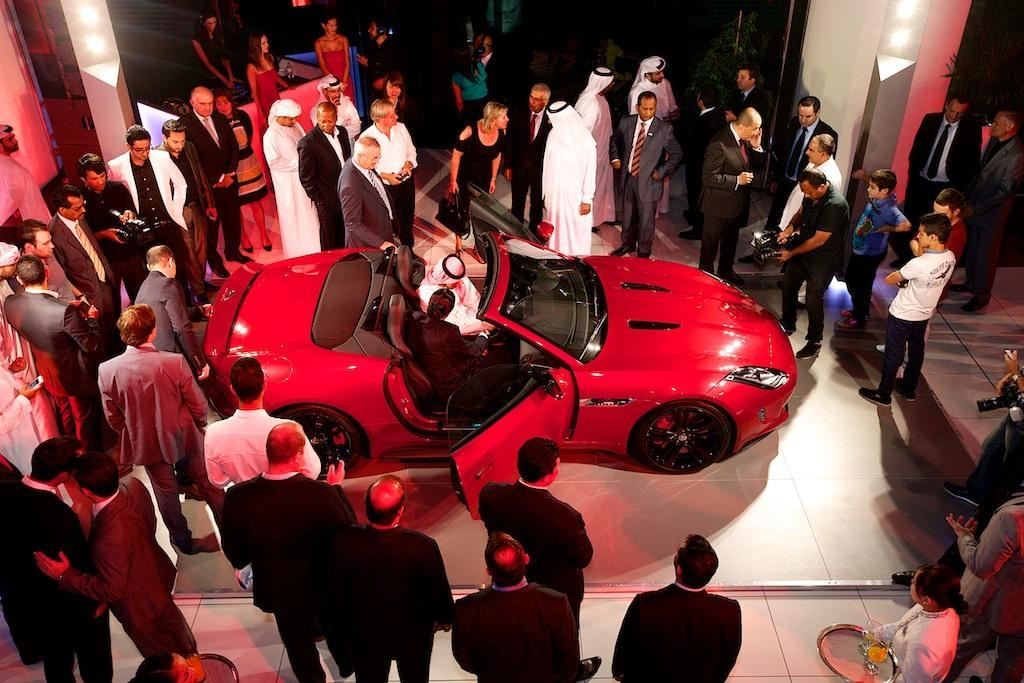What is the main subject of the picture? The main subject of the picture is a vehicle. What else can be seen in the picture besides the vehicle? There is a group of people, persons holding cameras, plants, lights, and other objects in the picture. What are the people holding in the picture? The persons holding cameras are holding cameras in the picture. What type of objects can be seen in the picture besides the vehicle and people? There are plants and lights in the picture, as well as other objects. What type of education can be seen in the picture? There is no indication of education in the picture; it features a vehicle, a group of people, persons holding cameras, plants, lights, and other objects. Can you tell me how many kittens are visible in the picture? There are no kittens present in the picture. 